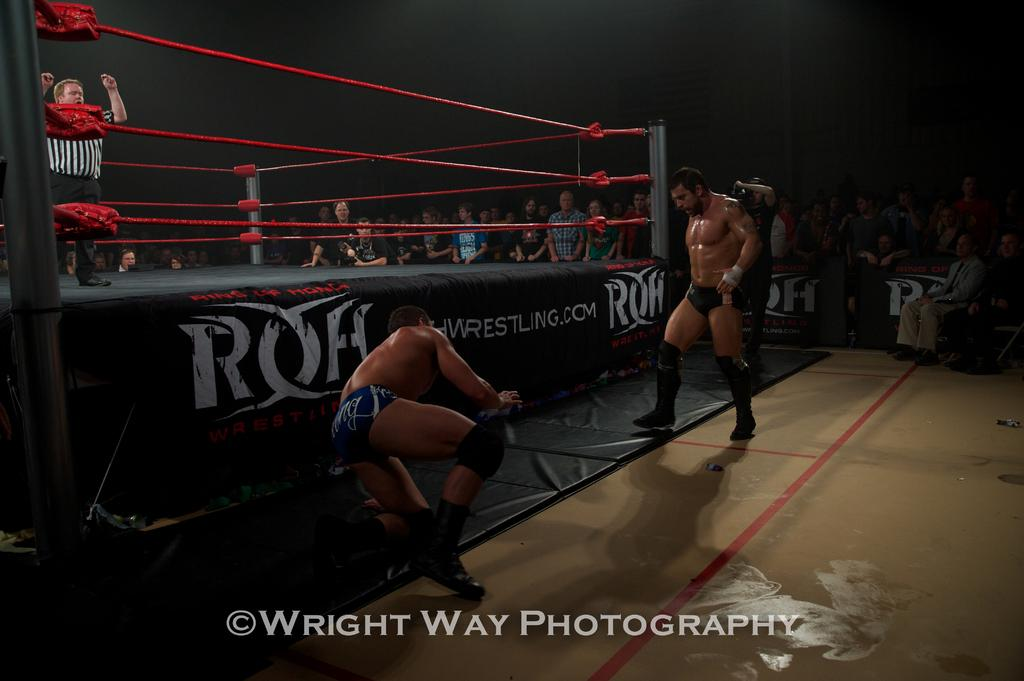<image>
Give a short and clear explanation of the subsequent image. A wrestling ring with the writing wrestling.com on it 